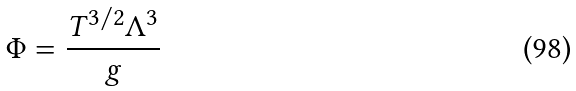<formula> <loc_0><loc_0><loc_500><loc_500>\Phi = \frac { T ^ { 3 / 2 } \Lambda ^ { 3 } } { g }</formula> 